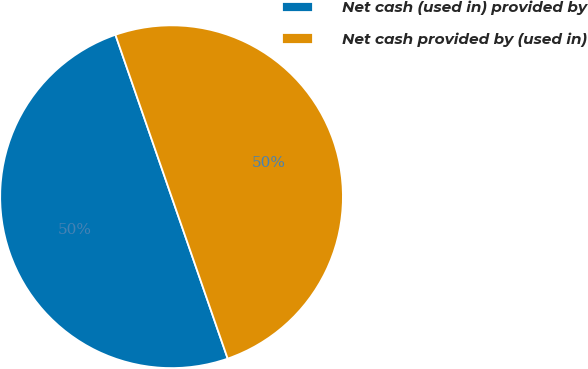<chart> <loc_0><loc_0><loc_500><loc_500><pie_chart><fcel>Net cash (used in) provided by<fcel>Net cash provided by (used in)<nl><fcel>50.0%<fcel>50.0%<nl></chart> 